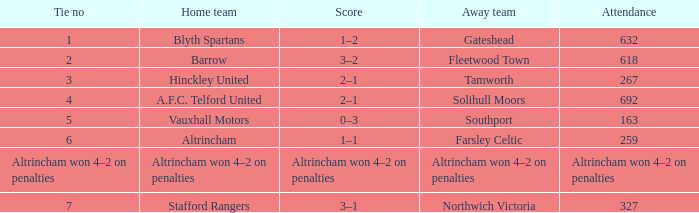What was the presence for the away team solihull moors? 692.0. 